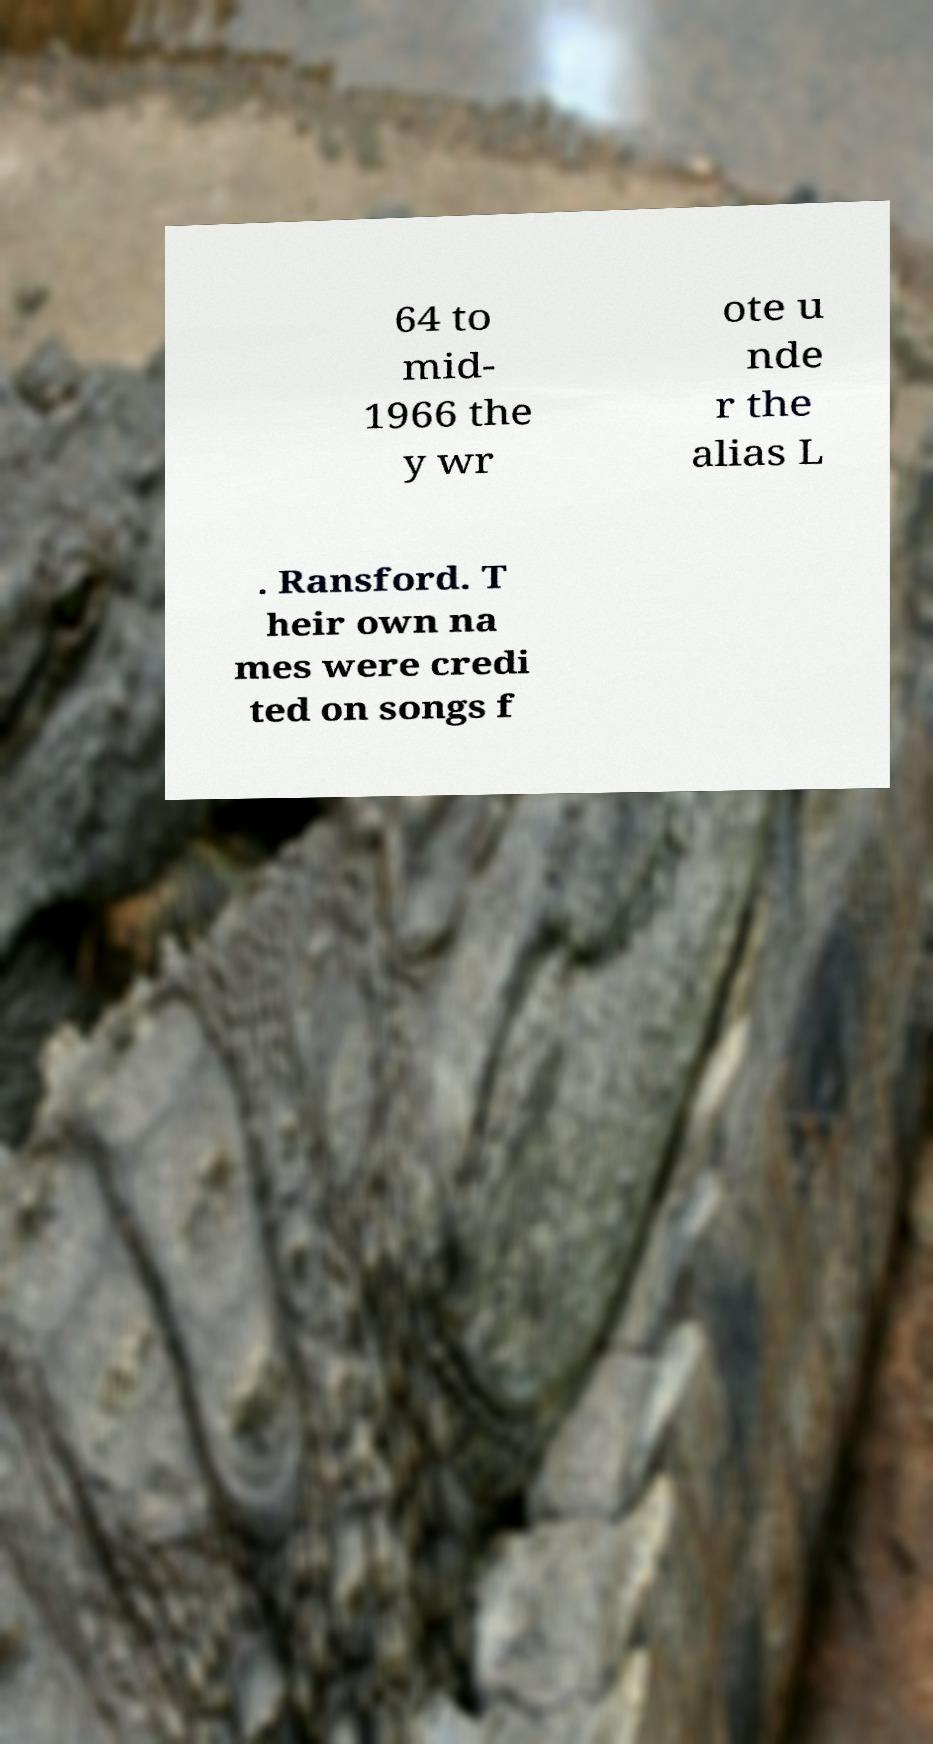Please identify and transcribe the text found in this image. 64 to mid- 1966 the y wr ote u nde r the alias L . Ransford. T heir own na mes were credi ted on songs f 